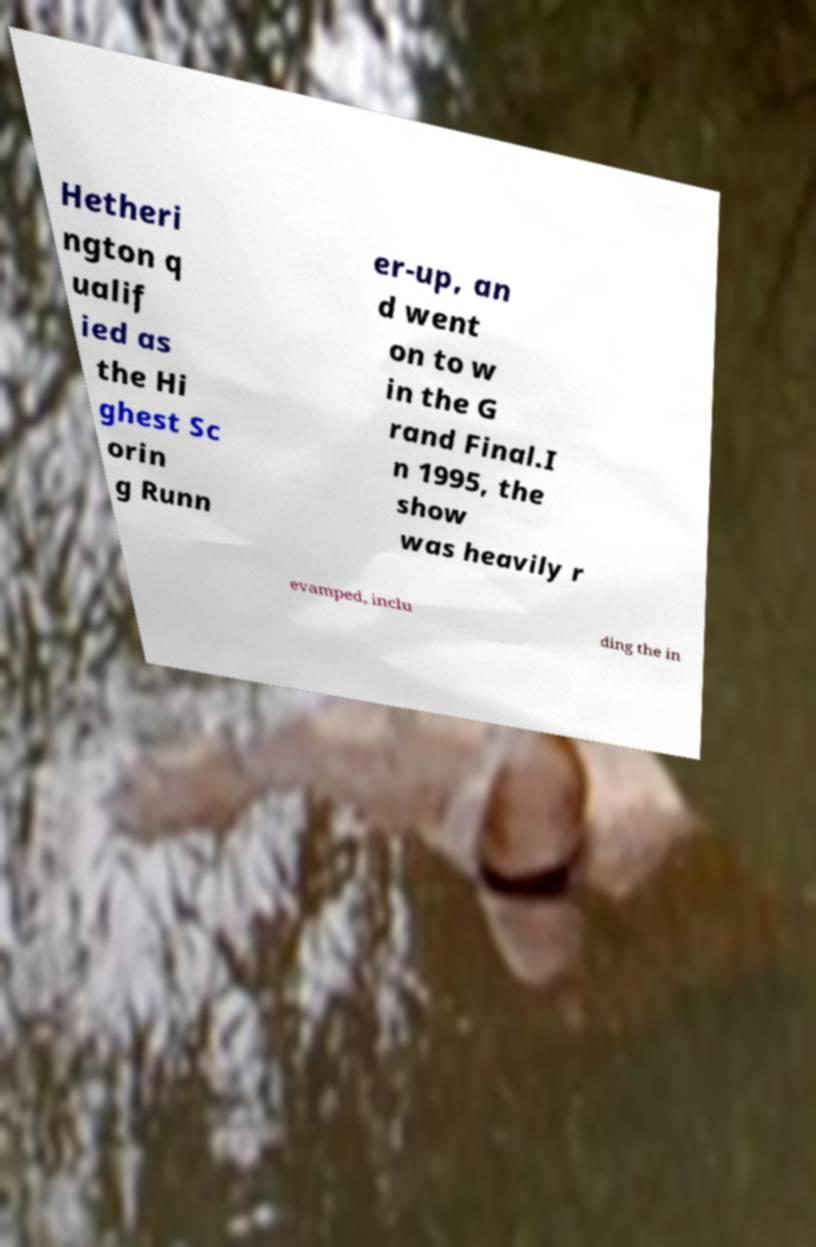Could you extract and type out the text from this image? Hetheri ngton q ualif ied as the Hi ghest Sc orin g Runn er-up, an d went on to w in the G rand Final.I n 1995, the show was heavily r evamped, inclu ding the in 